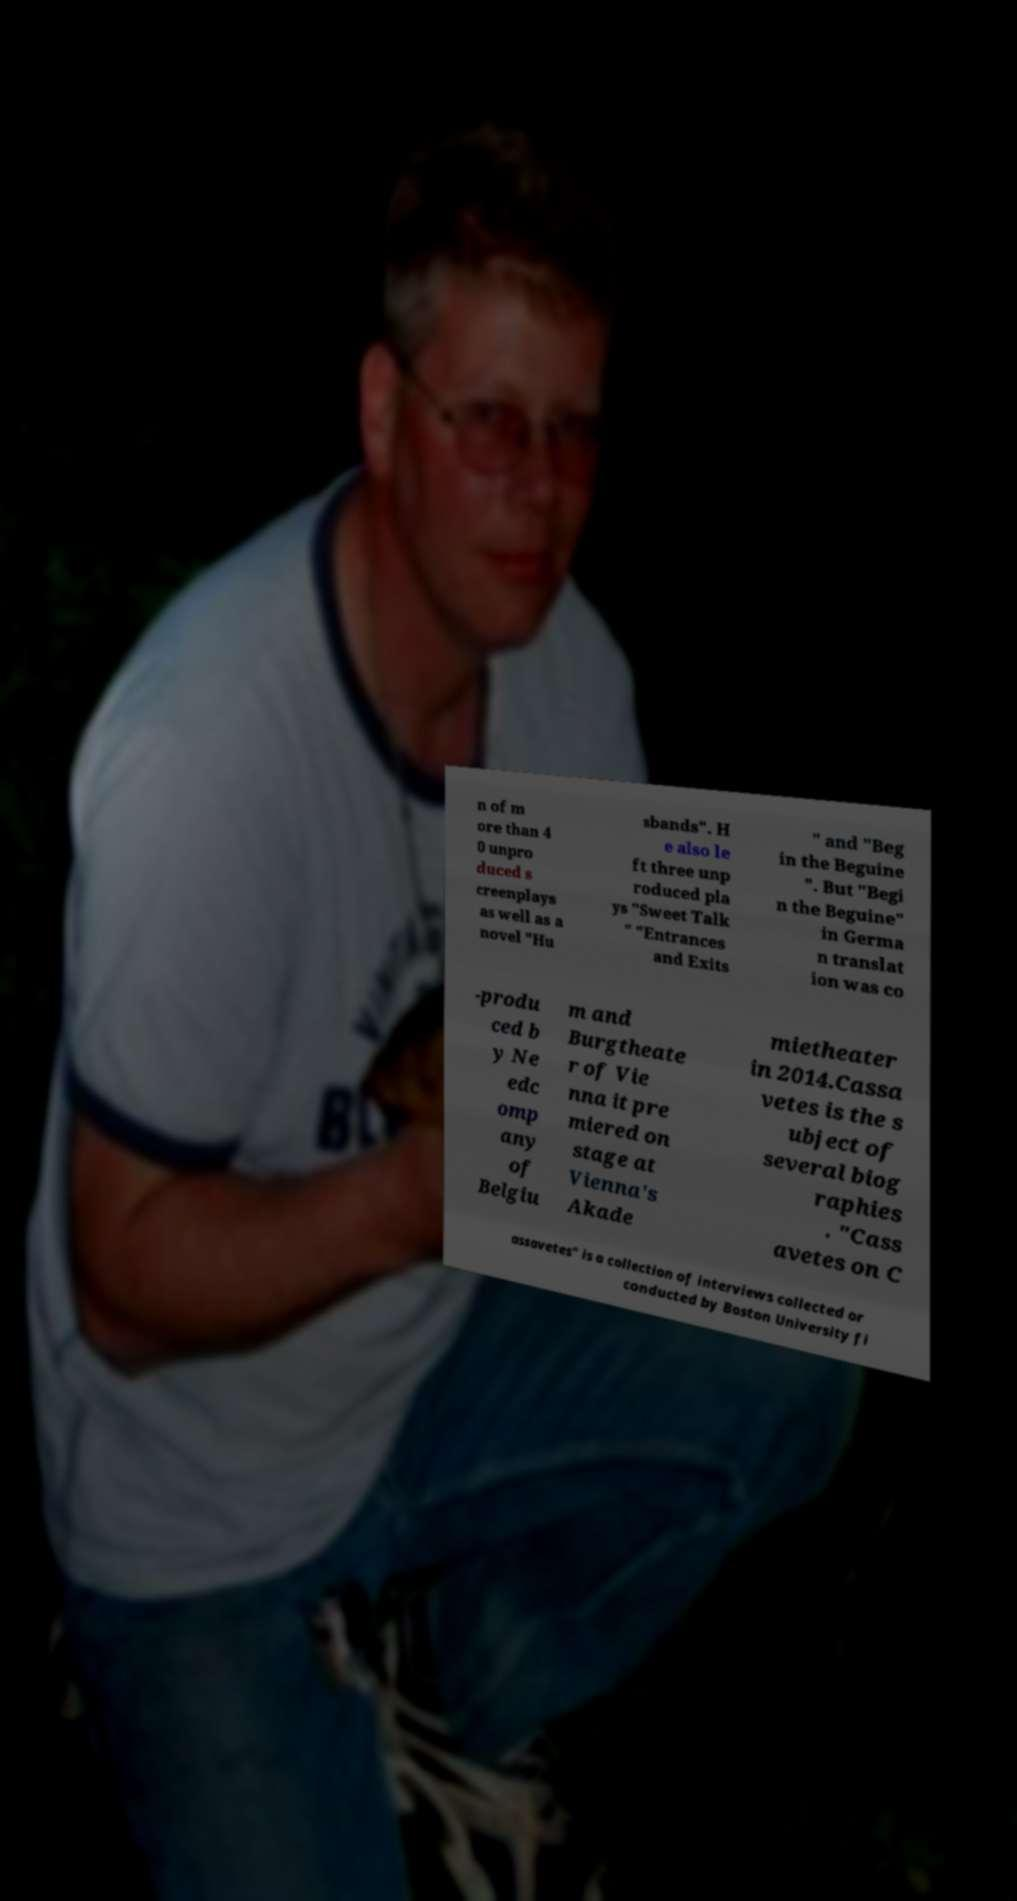Can you read and provide the text displayed in the image?This photo seems to have some interesting text. Can you extract and type it out for me? n of m ore than 4 0 unpro duced s creenplays as well as a novel "Hu sbands". H e also le ft three unp roduced pla ys "Sweet Talk " "Entrances and Exits " and "Beg in the Beguine ". But "Begi n the Beguine" in Germa n translat ion was co -produ ced b y Ne edc omp any of Belgiu m and Burgtheate r of Vie nna it pre miered on stage at Vienna's Akade mietheater in 2014.Cassa vetes is the s ubject of several biog raphies . "Cass avetes on C assavetes" is a collection of interviews collected or conducted by Boston University fi 